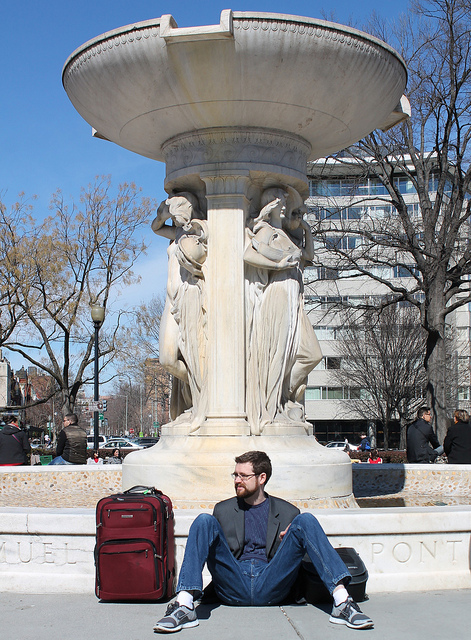Extract all visible text content from this image. PONT UEL 